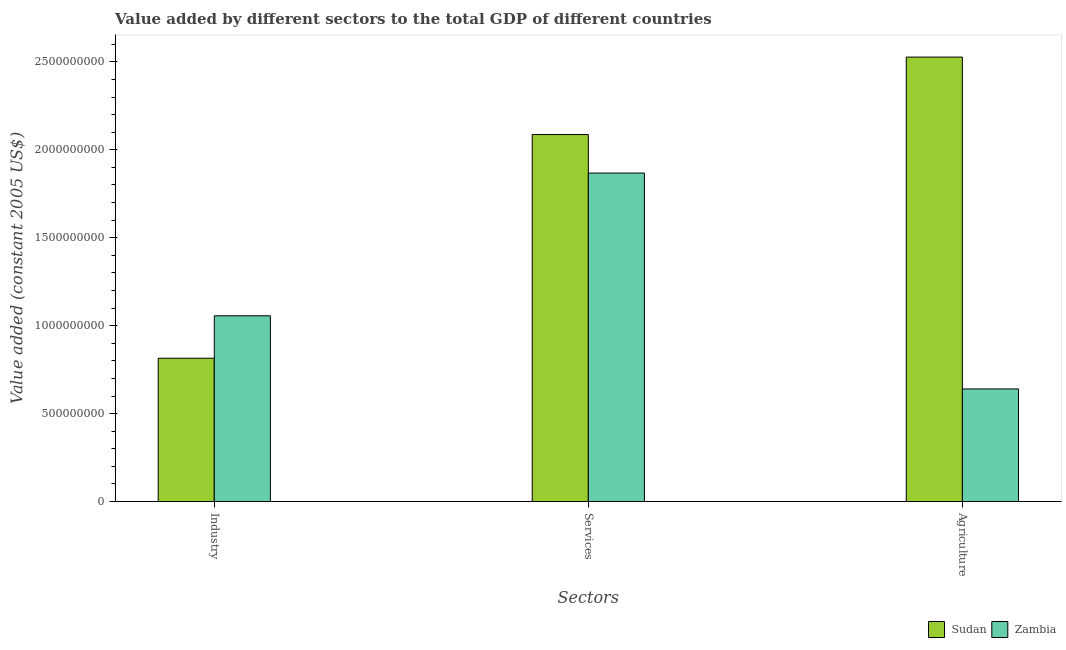How many different coloured bars are there?
Your response must be concise. 2. How many bars are there on the 1st tick from the left?
Your response must be concise. 2. What is the label of the 3rd group of bars from the left?
Ensure brevity in your answer.  Agriculture. What is the value added by industrial sector in Zambia?
Make the answer very short. 1.06e+09. Across all countries, what is the maximum value added by agricultural sector?
Provide a succinct answer. 2.53e+09. Across all countries, what is the minimum value added by agricultural sector?
Keep it short and to the point. 6.40e+08. In which country was the value added by industrial sector maximum?
Make the answer very short. Zambia. In which country was the value added by industrial sector minimum?
Provide a short and direct response. Sudan. What is the total value added by services in the graph?
Offer a very short reply. 3.95e+09. What is the difference between the value added by agricultural sector in Sudan and that in Zambia?
Your response must be concise. 1.89e+09. What is the difference between the value added by agricultural sector in Sudan and the value added by services in Zambia?
Your response must be concise. 6.59e+08. What is the average value added by industrial sector per country?
Your response must be concise. 9.36e+08. What is the difference between the value added by services and value added by agricultural sector in Sudan?
Ensure brevity in your answer.  -4.40e+08. What is the ratio of the value added by industrial sector in Sudan to that in Zambia?
Make the answer very short. 0.77. Is the value added by agricultural sector in Zambia less than that in Sudan?
Your response must be concise. Yes. What is the difference between the highest and the second highest value added by agricultural sector?
Make the answer very short. 1.89e+09. What is the difference between the highest and the lowest value added by services?
Offer a terse response. 2.19e+08. In how many countries, is the value added by industrial sector greater than the average value added by industrial sector taken over all countries?
Your answer should be compact. 1. What does the 1st bar from the left in Agriculture represents?
Make the answer very short. Sudan. What does the 2nd bar from the right in Industry represents?
Provide a succinct answer. Sudan. Is it the case that in every country, the sum of the value added by industrial sector and value added by services is greater than the value added by agricultural sector?
Your response must be concise. Yes. How many bars are there?
Keep it short and to the point. 6. Are all the bars in the graph horizontal?
Give a very brief answer. No. Are the values on the major ticks of Y-axis written in scientific E-notation?
Keep it short and to the point. No. Does the graph contain any zero values?
Give a very brief answer. No. Where does the legend appear in the graph?
Ensure brevity in your answer.  Bottom right. How many legend labels are there?
Keep it short and to the point. 2. What is the title of the graph?
Offer a very short reply. Value added by different sectors to the total GDP of different countries. Does "Bulgaria" appear as one of the legend labels in the graph?
Make the answer very short. No. What is the label or title of the X-axis?
Offer a very short reply. Sectors. What is the label or title of the Y-axis?
Provide a succinct answer. Value added (constant 2005 US$). What is the Value added (constant 2005 US$) in Sudan in Industry?
Your answer should be very brief. 8.15e+08. What is the Value added (constant 2005 US$) in Zambia in Industry?
Make the answer very short. 1.06e+09. What is the Value added (constant 2005 US$) in Sudan in Services?
Give a very brief answer. 2.09e+09. What is the Value added (constant 2005 US$) of Zambia in Services?
Provide a short and direct response. 1.87e+09. What is the Value added (constant 2005 US$) of Sudan in Agriculture?
Make the answer very short. 2.53e+09. What is the Value added (constant 2005 US$) of Zambia in Agriculture?
Keep it short and to the point. 6.40e+08. Across all Sectors, what is the maximum Value added (constant 2005 US$) of Sudan?
Offer a very short reply. 2.53e+09. Across all Sectors, what is the maximum Value added (constant 2005 US$) of Zambia?
Ensure brevity in your answer.  1.87e+09. Across all Sectors, what is the minimum Value added (constant 2005 US$) of Sudan?
Give a very brief answer. 8.15e+08. Across all Sectors, what is the minimum Value added (constant 2005 US$) in Zambia?
Make the answer very short. 6.40e+08. What is the total Value added (constant 2005 US$) in Sudan in the graph?
Ensure brevity in your answer.  5.43e+09. What is the total Value added (constant 2005 US$) of Zambia in the graph?
Provide a short and direct response. 3.56e+09. What is the difference between the Value added (constant 2005 US$) in Sudan in Industry and that in Services?
Your answer should be very brief. -1.27e+09. What is the difference between the Value added (constant 2005 US$) in Zambia in Industry and that in Services?
Your response must be concise. -8.12e+08. What is the difference between the Value added (constant 2005 US$) of Sudan in Industry and that in Agriculture?
Make the answer very short. -1.71e+09. What is the difference between the Value added (constant 2005 US$) in Zambia in Industry and that in Agriculture?
Offer a very short reply. 4.16e+08. What is the difference between the Value added (constant 2005 US$) of Sudan in Services and that in Agriculture?
Make the answer very short. -4.40e+08. What is the difference between the Value added (constant 2005 US$) of Zambia in Services and that in Agriculture?
Ensure brevity in your answer.  1.23e+09. What is the difference between the Value added (constant 2005 US$) in Sudan in Industry and the Value added (constant 2005 US$) in Zambia in Services?
Give a very brief answer. -1.05e+09. What is the difference between the Value added (constant 2005 US$) of Sudan in Industry and the Value added (constant 2005 US$) of Zambia in Agriculture?
Keep it short and to the point. 1.75e+08. What is the difference between the Value added (constant 2005 US$) of Sudan in Services and the Value added (constant 2005 US$) of Zambia in Agriculture?
Your response must be concise. 1.45e+09. What is the average Value added (constant 2005 US$) of Sudan per Sectors?
Make the answer very short. 1.81e+09. What is the average Value added (constant 2005 US$) of Zambia per Sectors?
Your answer should be compact. 1.19e+09. What is the difference between the Value added (constant 2005 US$) of Sudan and Value added (constant 2005 US$) of Zambia in Industry?
Provide a short and direct response. -2.41e+08. What is the difference between the Value added (constant 2005 US$) in Sudan and Value added (constant 2005 US$) in Zambia in Services?
Offer a terse response. 2.19e+08. What is the difference between the Value added (constant 2005 US$) in Sudan and Value added (constant 2005 US$) in Zambia in Agriculture?
Provide a short and direct response. 1.89e+09. What is the ratio of the Value added (constant 2005 US$) of Sudan in Industry to that in Services?
Your answer should be compact. 0.39. What is the ratio of the Value added (constant 2005 US$) of Zambia in Industry to that in Services?
Provide a succinct answer. 0.57. What is the ratio of the Value added (constant 2005 US$) in Sudan in Industry to that in Agriculture?
Offer a terse response. 0.32. What is the ratio of the Value added (constant 2005 US$) in Zambia in Industry to that in Agriculture?
Your answer should be compact. 1.65. What is the ratio of the Value added (constant 2005 US$) of Sudan in Services to that in Agriculture?
Your answer should be compact. 0.83. What is the ratio of the Value added (constant 2005 US$) of Zambia in Services to that in Agriculture?
Your response must be concise. 2.92. What is the difference between the highest and the second highest Value added (constant 2005 US$) in Sudan?
Give a very brief answer. 4.40e+08. What is the difference between the highest and the second highest Value added (constant 2005 US$) of Zambia?
Your answer should be very brief. 8.12e+08. What is the difference between the highest and the lowest Value added (constant 2005 US$) in Sudan?
Ensure brevity in your answer.  1.71e+09. What is the difference between the highest and the lowest Value added (constant 2005 US$) in Zambia?
Keep it short and to the point. 1.23e+09. 